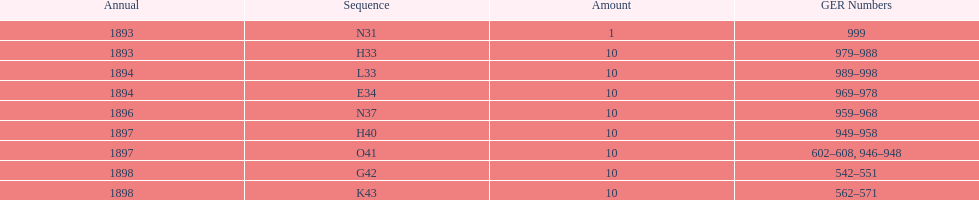What is the number of years with a quantity of 10? 5. 